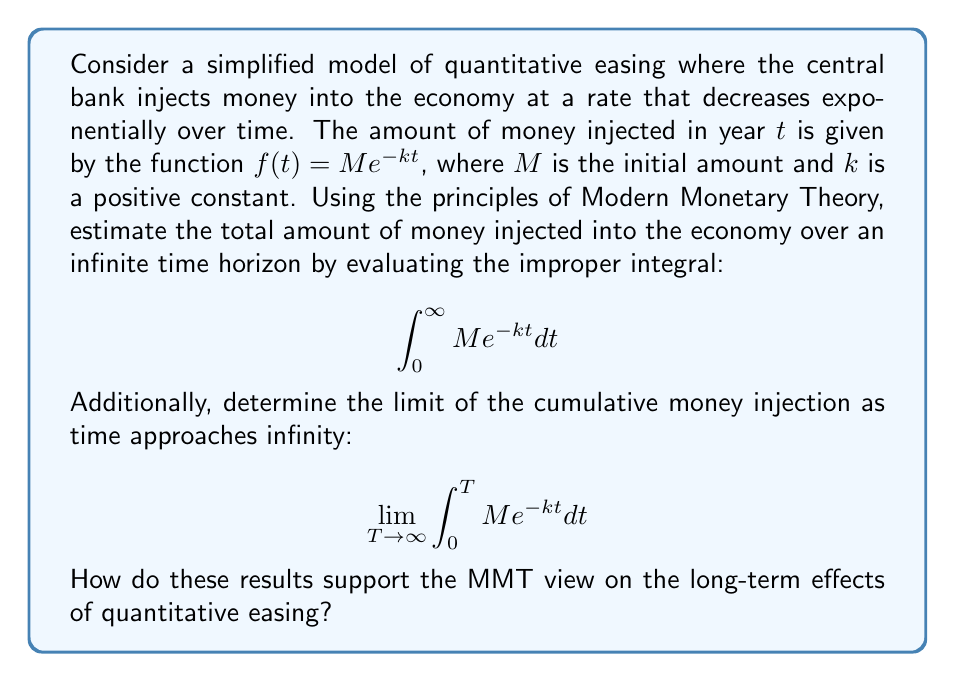Can you solve this math problem? To solve this problem, we'll use integration techniques and limits from calculus:

1) First, let's evaluate the improper integral:

   $$\int_0^\infty M e^{-kt} dt$$

   We can solve this using the following steps:
   
   a) Factor out the constant $M$:
      $$M \int_0^\infty e^{-kt} dt$$

   b) Use the substitution $u = -kt$, $du = -k dt$, $dt = -\frac{1}{k}du$:
      $$M \cdot -\frac{1}{k} \int_{0}^{-\infty} e^u du$$

   c) Evaluate the integral:
      $$M \cdot -\frac{1}{k} [e^u]_{0}^{-\infty} = M \cdot -\frac{1}{k} [0 - 1] = \frac{M}{k}$$

2) Now, let's determine the limit:

   $$\lim_{T \to \infty} \int_0^T M e^{-kt} dt$$

   We can solve this using the following steps:
   
   a) Evaluate the definite integral:
      $$\int_0^T M e^{-kt} dt = -\frac{M}{k} [e^{-kt}]_0^T = -\frac{M}{k} [e^{-kT} - 1]$$

   b) Take the limit as $T$ approaches infinity:
      $$\lim_{T \to \infty} -\frac{M}{k} [e^{-kT} - 1] = -\frac{M}{k} [\lim_{T \to \infty} e^{-kT} - 1] = -\frac{M}{k} [0 - 1] = \frac{M}{k}$$

3) Interpretation in the context of MMT:

   The result $\frac{M}{k}$ represents the total amount of money injected into the economy over an infinite time horizon. This finite value, despite an infinite time period, supports the MMT view that controlled money creation through quantitative easing does not lead to infinite inflation. 

   The fact that the limit equals the improper integral suggests that the long-term effects of quantitative easing stabilize, aligning with MMT's stance that monetary policy can be used effectively for economic stimulation without necessarily leading to detrimental long-term consequences.
Answer: The total amount of money injected into the economy over an infinite time horizon is $\frac{M}{k}$. This is also the limit of the cumulative money injection as time approaches infinity. These results support the MMT view that quantitative easing can be a controlled and effective tool for economic stimulation, with finite and manageable long-term effects. 